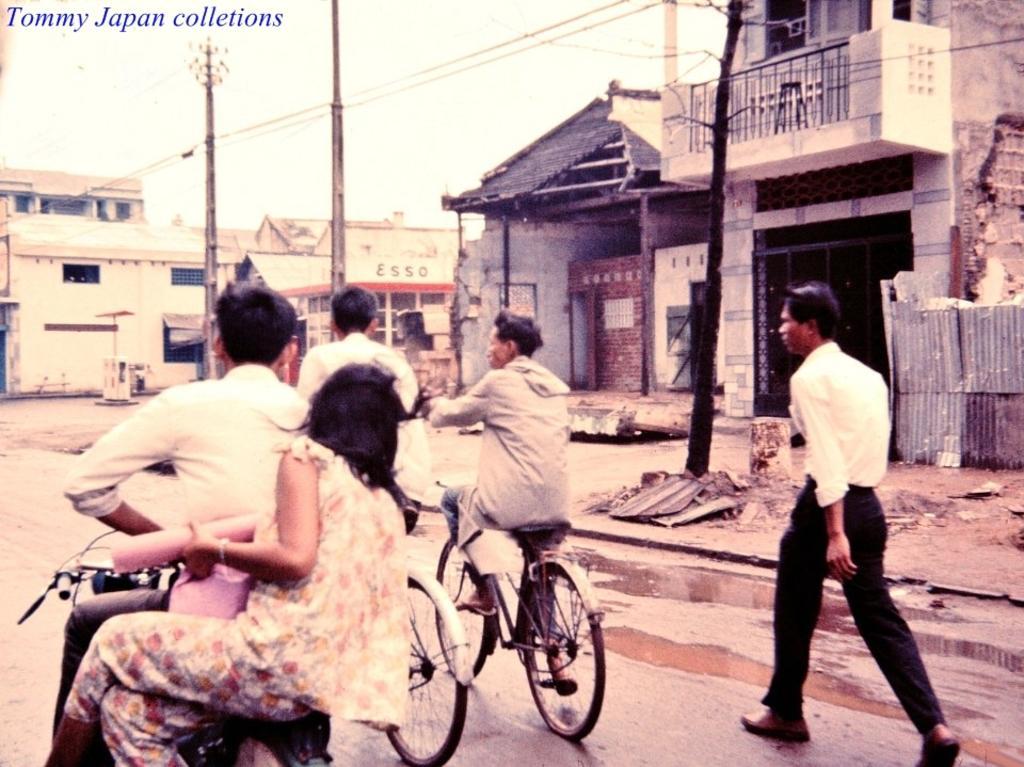How would you summarize this image in a sentence or two? In the image we can see five persons, in the center the four persons were on the bicycle. And on the right side one man he is walking on the road. And coming to the background there is a building in white color. 